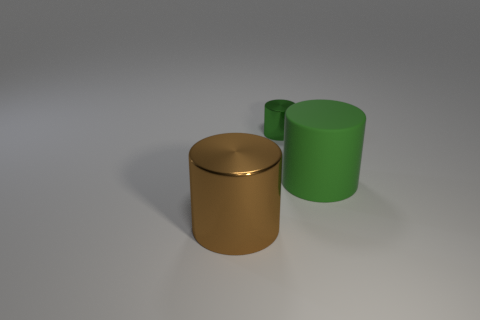Is there anything else that has the same size as the green shiny cylinder?
Provide a short and direct response. No. The big green object right of the metallic cylinder that is right of the brown cylinder is what shape?
Make the answer very short. Cylinder. Are the big cylinder that is on the left side of the green metal thing and the thing behind the large rubber object made of the same material?
Offer a terse response. Yes. There is a big cylinder behind the brown metal thing; what number of things are on the left side of it?
Give a very brief answer. 2. There is a big rubber object that is right of the tiny shiny object; does it have the same shape as the green thing that is behind the rubber cylinder?
Offer a very short reply. Yes. There is a object that is both in front of the tiny metallic thing and on the left side of the large green object; how big is it?
Ensure brevity in your answer.  Large. The small metal object that is the same shape as the large green rubber thing is what color?
Offer a very short reply. Green. The metallic thing that is in front of the green object to the left of the large rubber thing is what color?
Your answer should be compact. Brown. What shape is the small green shiny object?
Keep it short and to the point. Cylinder. There is a thing that is both in front of the tiny cylinder and on the left side of the green matte thing; what shape is it?
Make the answer very short. Cylinder. 